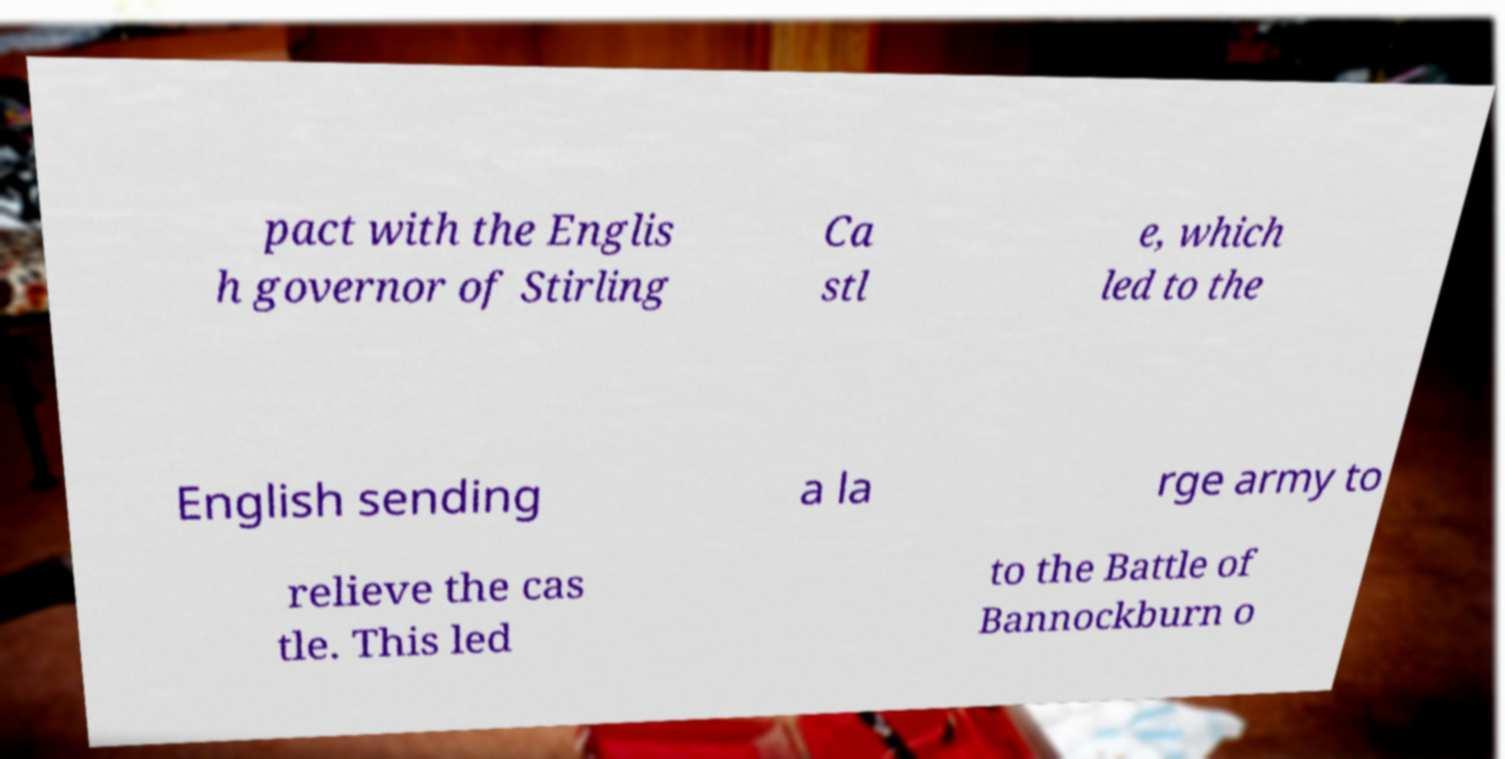There's text embedded in this image that I need extracted. Can you transcribe it verbatim? pact with the Englis h governor of Stirling Ca stl e, which led to the English sending a la rge army to relieve the cas tle. This led to the Battle of Bannockburn o 